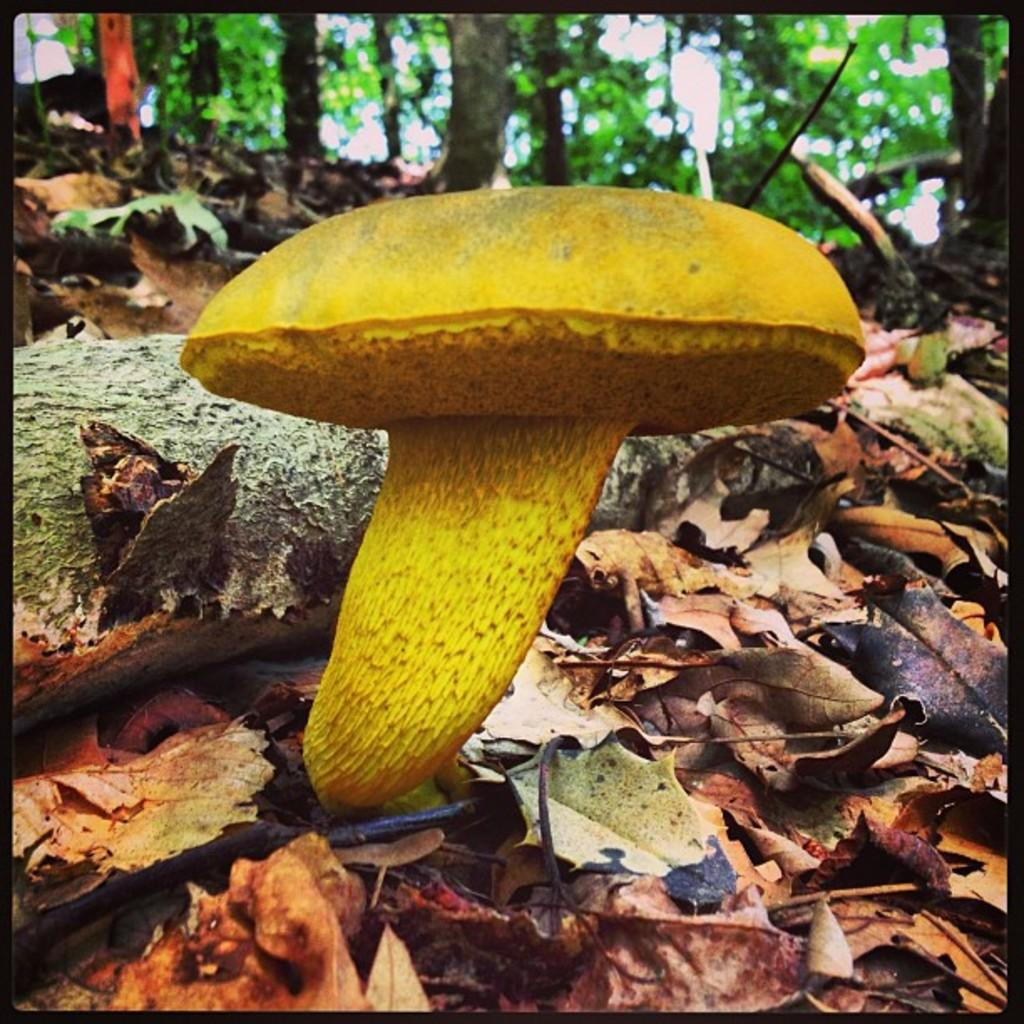What is the main subject of the image? There is a mushroom in the image. What else can be seen in the image besides the mushroom? There are dried leaves in the image. What is visible in the background of the image? There are trees in the background of the image. What type of transport can be seen in the image? There is no transport visible in the image; it features a mushroom, dried leaves, and trees in the background. What dish is being prepared for dinner in the image? There is no indication of a dish being prepared for dinner in the image. 